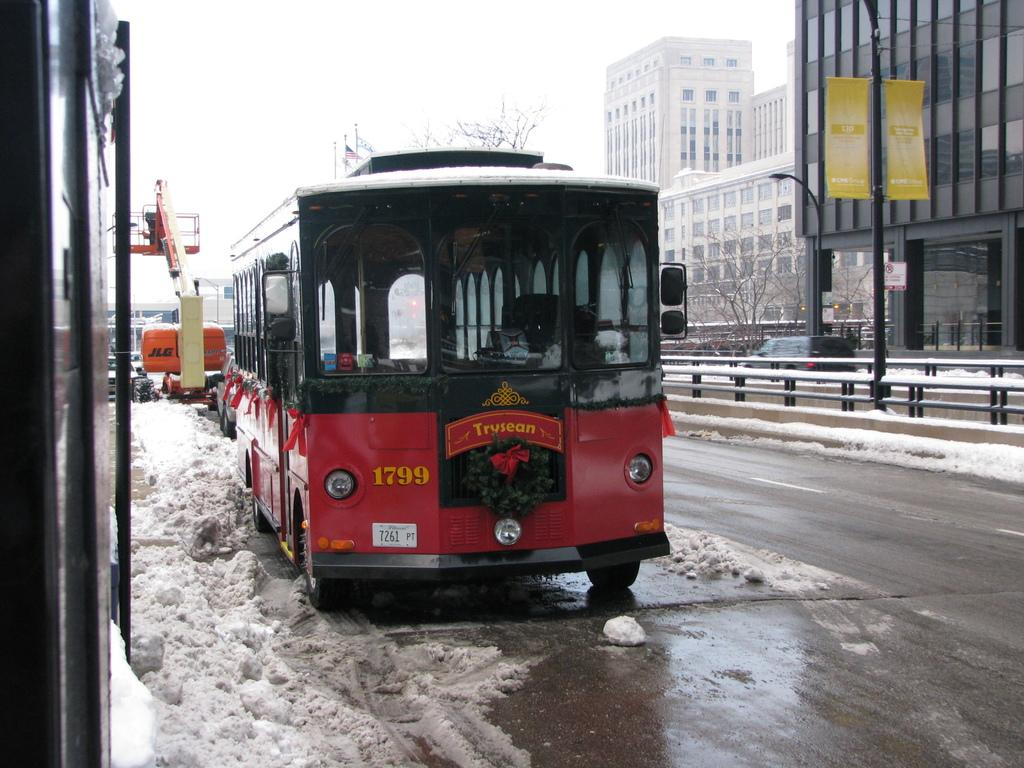<image>
Write a terse but informative summary of the picture. a red trolley car  with the number 1799 going past a dirty snowbank 